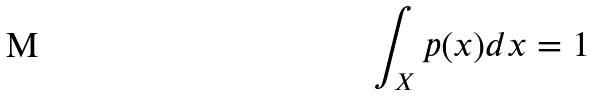<formula> <loc_0><loc_0><loc_500><loc_500>\int _ { X } p ( x ) d x = 1</formula> 